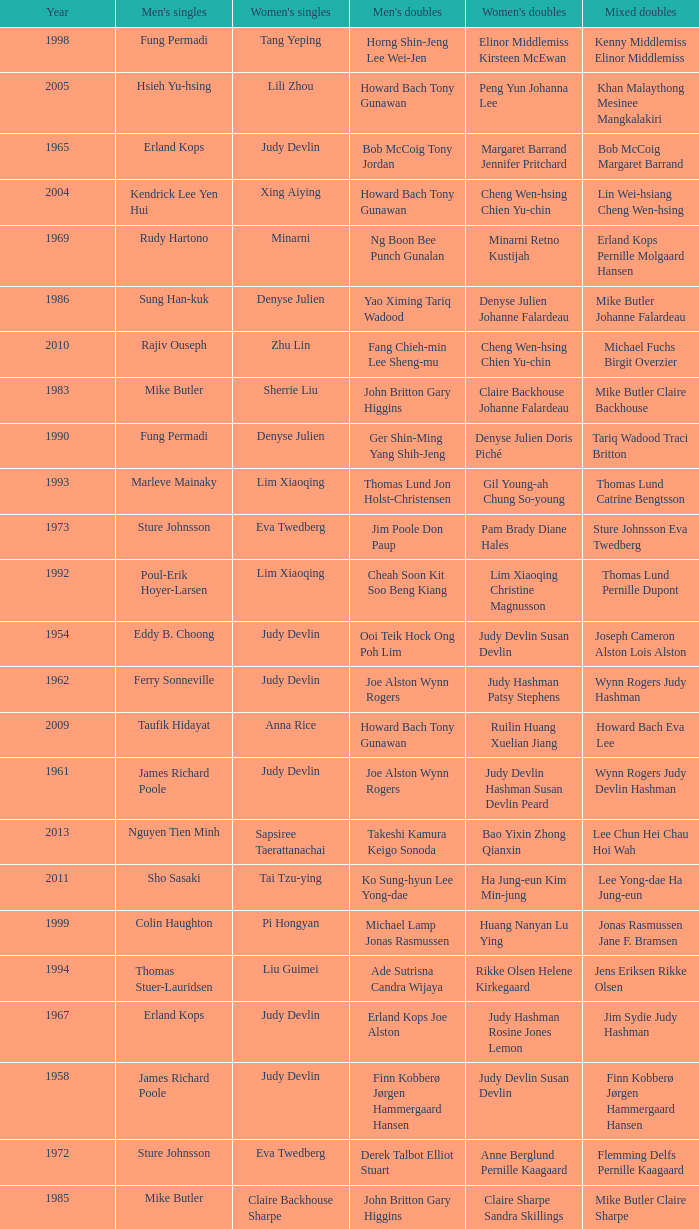Who were the men's doubles champions when the men's singles champion was muljadi? Ng Boon Bee Punch Gunalan. 